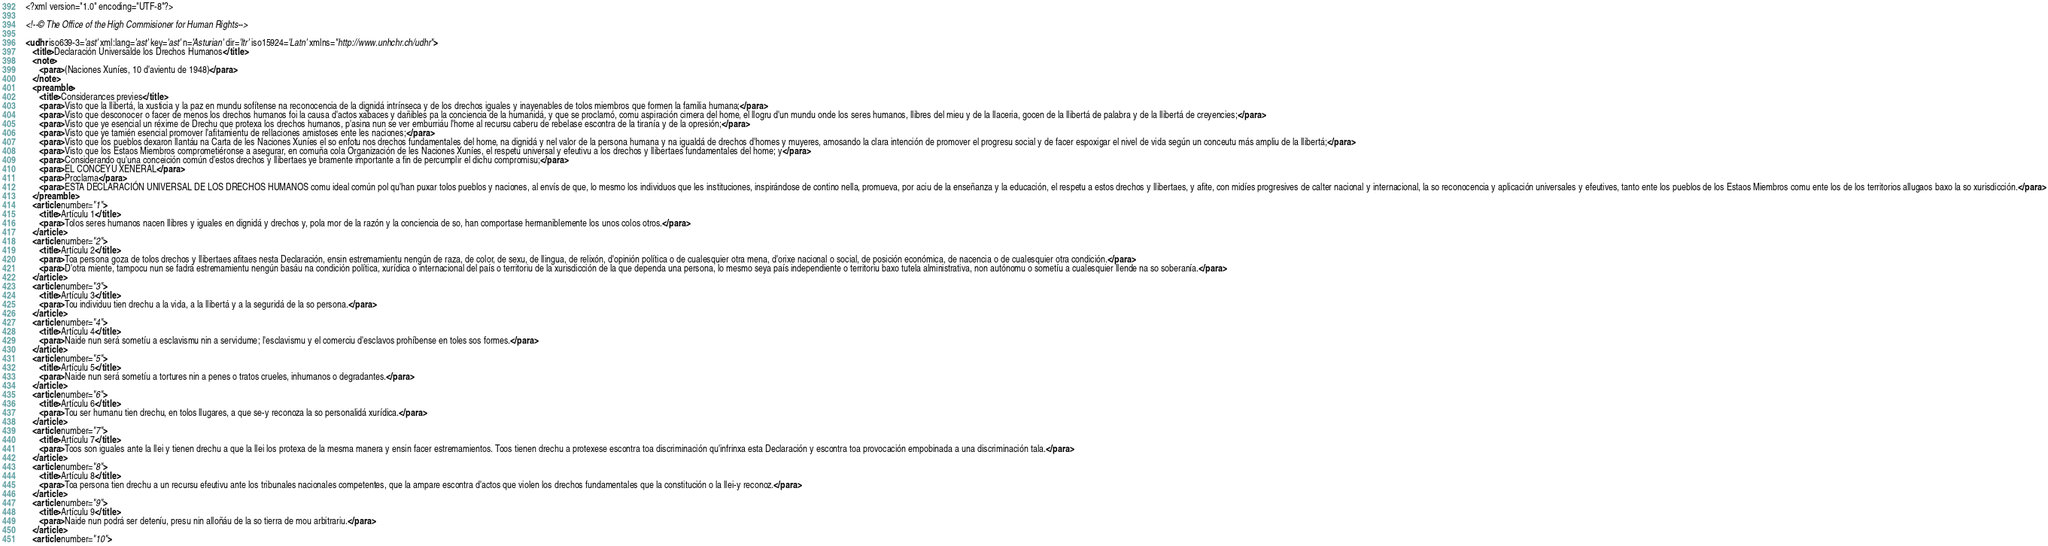<code> <loc_0><loc_0><loc_500><loc_500><_XML_><?xml version="1.0" encoding="UTF-8"?>

<!--© The Office of the High Commisioner for Human Rights-->

<udhr iso639-3='ast' xml:lang='ast' key='ast' n='Asturian' dir='ltr' iso15924='Latn' xmlns="http://www.unhchr.ch/udhr">
   <title>Declaración Universalde los Drechos Humanos</title>
   <note>
      <para>(Naciones Xuníes, 10 d'avientu de 1948)</para>
   </note>
   <preamble>
      <title>Considerances previes</title>
      <para>Visto que la llibertá, la xusticia y la paz en mundu sofítense na reconocencia de la dignidá intrínseca y de los drechos iguales y inayenables de tolos miembros que formen la familia humana;</para>
      <para>Visto que desconocer o facer de menos los drechos humanos foi la causa d'actos xabaces y dañibles pa la conciencia de la humanidá, y que se proclamó, comu aspiración cimera del home, el llogru d'un mundu onde los seres humanos, llibres del mieu y de la llaceria, gocen de la llibertá de palabra y de la llibertá de creyencies;</para>
      <para>Visto que ye esencial un réxime de Drechu que protexa los drechos humanos, p'asina nun se ver emburriáu l'home al recursu caberu de rebelase escontra de la tiranía y de la opresión;</para>
      <para>Visto que ye tamién esencial promover l'afitamientu de rellaciones amistoses ente les naciones;</para>
      <para>Visto que los pueblos dexaron llantáu na Carta de les Naciones Xuníes el so enfotu nos drechos fundamentales del home, na dignidá y nel valor de la persona humana y na igualdá de drechos d'homes y muyeres, amosando la clara intención de promover el progresu social y de facer espoxigar el nivel de vida según un conceutu más ampliu de la llibertá;</para>
      <para>Visto que los Estaos Miembros comprometiéronse a asegurar, en comuña cola Organización de les Naciones Xuníes, el respetu universal y efeutivu a los drechos y llibertaes fundamentales del home; y</para>
      <para>Considerando qu'una conceición común d'estos drechos y llibertaes ye bramente importante a fin de percumplir el dichu compromisu;</para>
      <para>EL CONCEYU XENERAL</para>
      <para>Proclama</para>
      <para>ESTA DECLARACIÓN UNIVERSAL DE LOS DRECHOS HUMANOS comu ideal común pol qu'han puxar tolos pueblos y naciones, al envís de que, lo mesmo los individuos que les instituciones, inspirándose de contino nella, promueva, por aciu de la enseñanza y la educación, el respetu a estos drechos y llibertaes, y afite, con midíes progresives de calter nacional y internacional, la so reconocencia y aplicación universales y efeutives, tanto ente los pueblos de los Estaos Miembros comu ente los de los territorios allugaos baxo la so xurisdicción.</para>
   </preamble>
   <article number="1">
      <title>Artículu 1</title>
      <para>Tolos seres humanos nacen llibres y iguales en dignidá y drechos y, pola mor de la razón y la conciencia de so, han comportase hermaniblemente los unos colos otros.</para>
   </article>
   <article number="2">
      <title>Artículu 2</title>
      <para>Toa persona goza de tolos drechos y llibertaes afitaes nesta Declaración, ensin estremamientu nengún de raza, de color, de sexu, de llingua, de relixón, d'opinión política o de cualesquier otra mena, d'orixe nacional o social, de posición económica, de nacencia o de cualesquier otra condición.</para>
      <para>D'otra miente, tampocu nun se fadrá estremamientu nengún basáu na condición política, xurídica o internacional del país o territoriu de la xurisdicción de la que dependa una persona, lo mesmo seya país independiente o territoriu baxo tutela alministrativa, non autónomu o sometíu a cualesquier llende na so soberanía.</para>
   </article>
   <article number="3">
      <title>Artículu 3</title>
      <para>Tou individuu tien drechu a la vida, a la llibertá y a la seguridá de la so persona.</para>
   </article>
   <article number="4">
      <title>Artículu 4</title>
      <para>Naide nun será sometíu a esclavismu nin a servidume; l'esclavismu y el comerciu d'esclavos prohíbense en toles sos formes.</para>
   </article>
   <article number="5">
      <title>Artículu 5</title>
      <para>Naide nun será sometíu a tortures nin a penes o tratos crueles, inhumanos o degradantes.</para>
   </article>
   <article number="6">
      <title>Artículu 6</title>
      <para>Tou ser humanu tien drechu, en tolos llugares, a que se-y reconoza la so personalidá xurídica.</para>
   </article>
   <article number="7">
      <title>Artículu 7</title>
      <para>Toos son iguales ante la llei y tienen drechu a que la llei los protexa de la mesma manera y ensin facer estremamientos. Toos tienen drechu a protexese escontra toa discriminación qu'infrinxa esta Declaración y escontra toa provocación empobinada a una discriminación tala.</para>
   </article>
   <article number="8">
      <title>Artículu 8</title>
      <para>Toa persona tien drechu a un recursu efeutivu ante los tribunales nacionales competentes, que la ampare escontra d'actos que violen los drechos fundamentales que la constitución o la llei-y reconoz.</para>
   </article>
   <article number="9">
      <title>Artículu 9</title>
      <para>Naide nun podrá ser deteníu, presu nin alloñáu de la so tierra de mou arbitrariu.</para>
   </article>
   <article number="10"></code> 